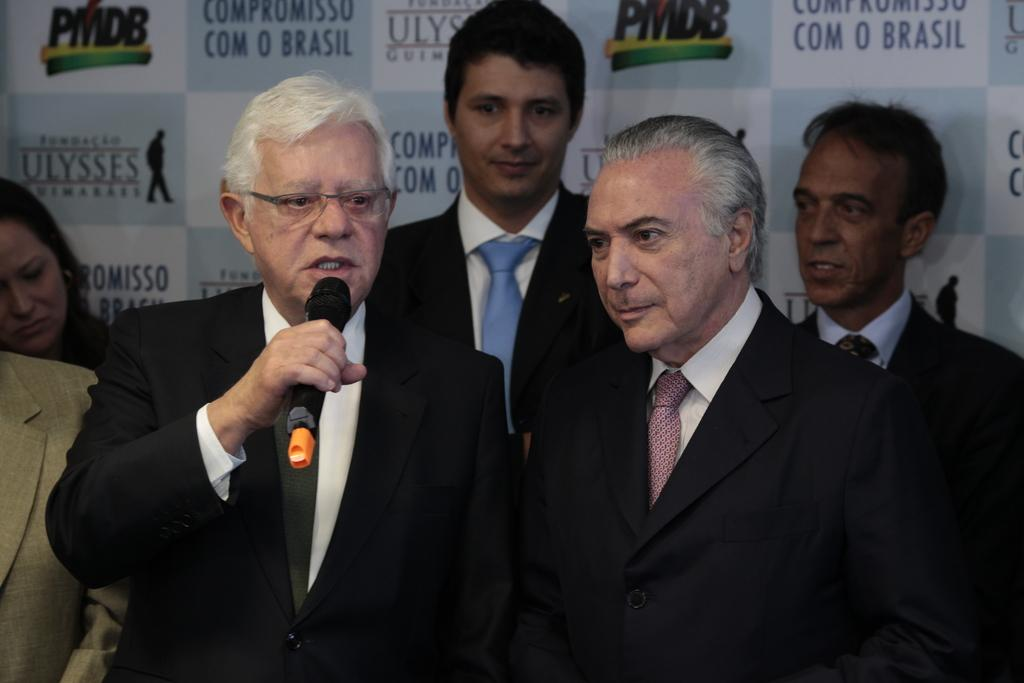How many people are in the image? There are people in the image, but the exact number is not specified. What is one person doing in the image? One person is holding a mic. What is the person holding the mic doing? The person holding the mic is speaking. What can be seen in the background of the image? There is a banner in the background of the image. What type of food is being served at the company event in the image? There is no mention of a company event or food in the image. The image only shows people, one of whom is holding a mic and speaking, and a banner in the background. 